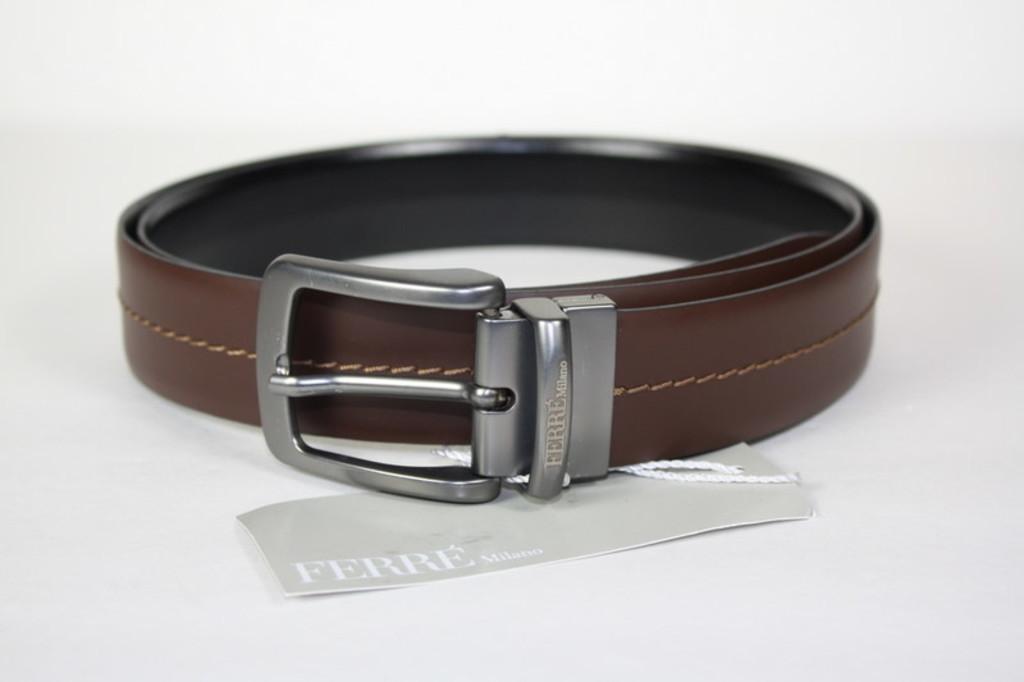Can you describe this image briefly? In this image I can see a leather belt to which a piece of paper is attached. On this paper I can see some text. The background is in white color. 